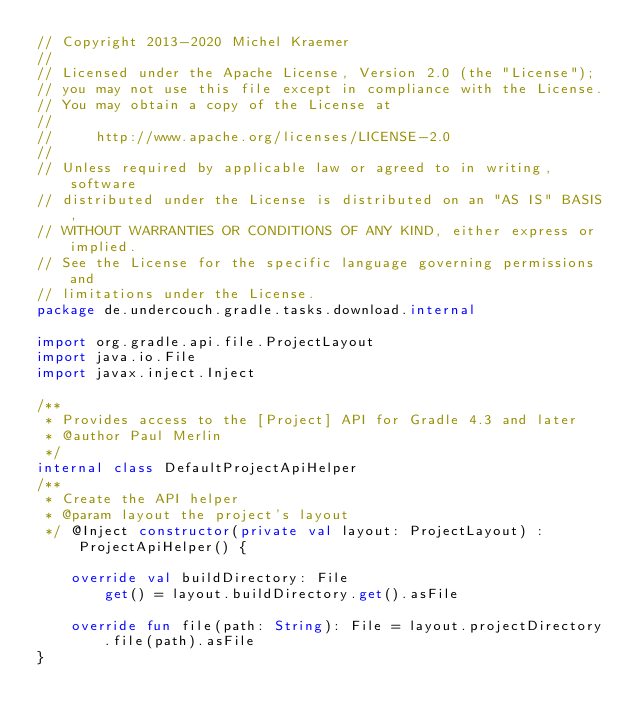<code> <loc_0><loc_0><loc_500><loc_500><_Kotlin_>// Copyright 2013-2020 Michel Kraemer
//
// Licensed under the Apache License, Version 2.0 (the "License");
// you may not use this file except in compliance with the License.
// You may obtain a copy of the License at
//
//     http://www.apache.org/licenses/LICENSE-2.0
//
// Unless required by applicable law or agreed to in writing, software
// distributed under the License is distributed on an "AS IS" BASIS,
// WITHOUT WARRANTIES OR CONDITIONS OF ANY KIND, either express or implied.
// See the License for the specific language governing permissions and
// limitations under the License.
package de.undercouch.gradle.tasks.download.internal

import org.gradle.api.file.ProjectLayout
import java.io.File
import javax.inject.Inject

/**
 * Provides access to the [Project] API for Gradle 4.3 and later
 * @author Paul Merlin
 */
internal class DefaultProjectApiHelper
/**
 * Create the API helper
 * @param layout the project's layout
 */ @Inject constructor(private val layout: ProjectLayout) : ProjectApiHelper() {

    override val buildDirectory: File
        get() = layout.buildDirectory.get().asFile

    override fun file(path: String): File = layout.projectDirectory.file(path).asFile
}</code> 